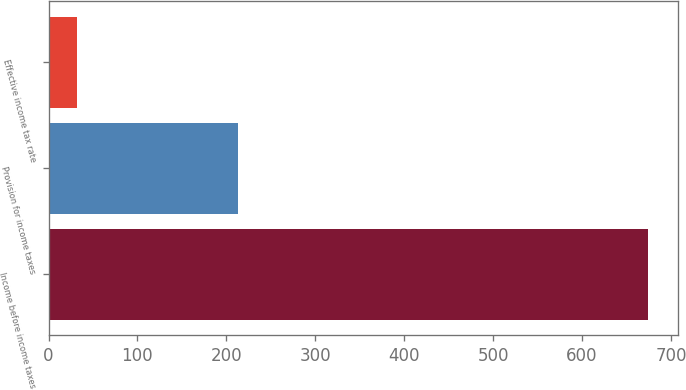<chart> <loc_0><loc_0><loc_500><loc_500><bar_chart><fcel>Income before income taxes<fcel>Provision for income taxes<fcel>Effective income tax rate<nl><fcel>674.8<fcel>213.3<fcel>31.6<nl></chart> 